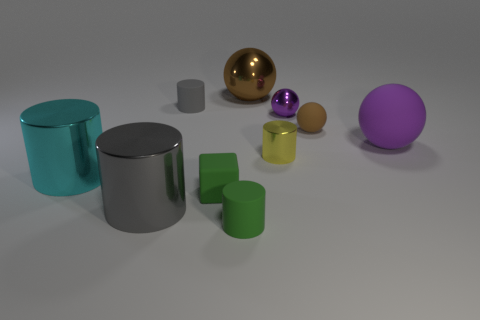There is a gray cylinder that is in front of the gray object behind the purple matte object; is there a green rubber cylinder that is right of it?
Keep it short and to the point. Yes. How many objects are either small things that are in front of the tiny brown rubber thing or objects that are to the left of the tiny purple metal thing?
Your response must be concise. 7. Does the big ball that is to the right of the brown metal sphere have the same material as the small green cube?
Provide a short and direct response. Yes. There is a sphere that is to the left of the big rubber ball and right of the purple shiny sphere; what is its material?
Offer a very short reply. Rubber. The cylinder that is right of the shiny sphere that is left of the yellow shiny thing is what color?
Provide a short and direct response. Yellow. There is a cyan thing that is the same shape as the tiny yellow metallic thing; what is its material?
Give a very brief answer. Metal. There is a small matte cylinder that is in front of the brown ball in front of the large metallic thing behind the tiny yellow cylinder; what is its color?
Your response must be concise. Green. What number of objects are either large green cylinders or large metallic things?
Offer a very short reply. 3. What number of brown things have the same shape as the gray matte thing?
Ensure brevity in your answer.  0. Does the block have the same material as the gray cylinder in front of the brown rubber ball?
Your answer should be compact. No. 